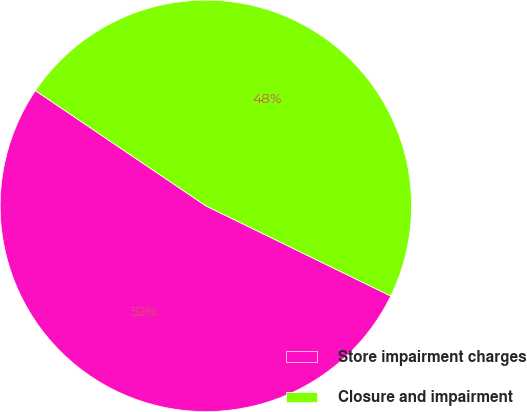Convert chart to OTSL. <chart><loc_0><loc_0><loc_500><loc_500><pie_chart><fcel>Store impairment charges<fcel>Closure and impairment<nl><fcel>52.24%<fcel>47.76%<nl></chart> 